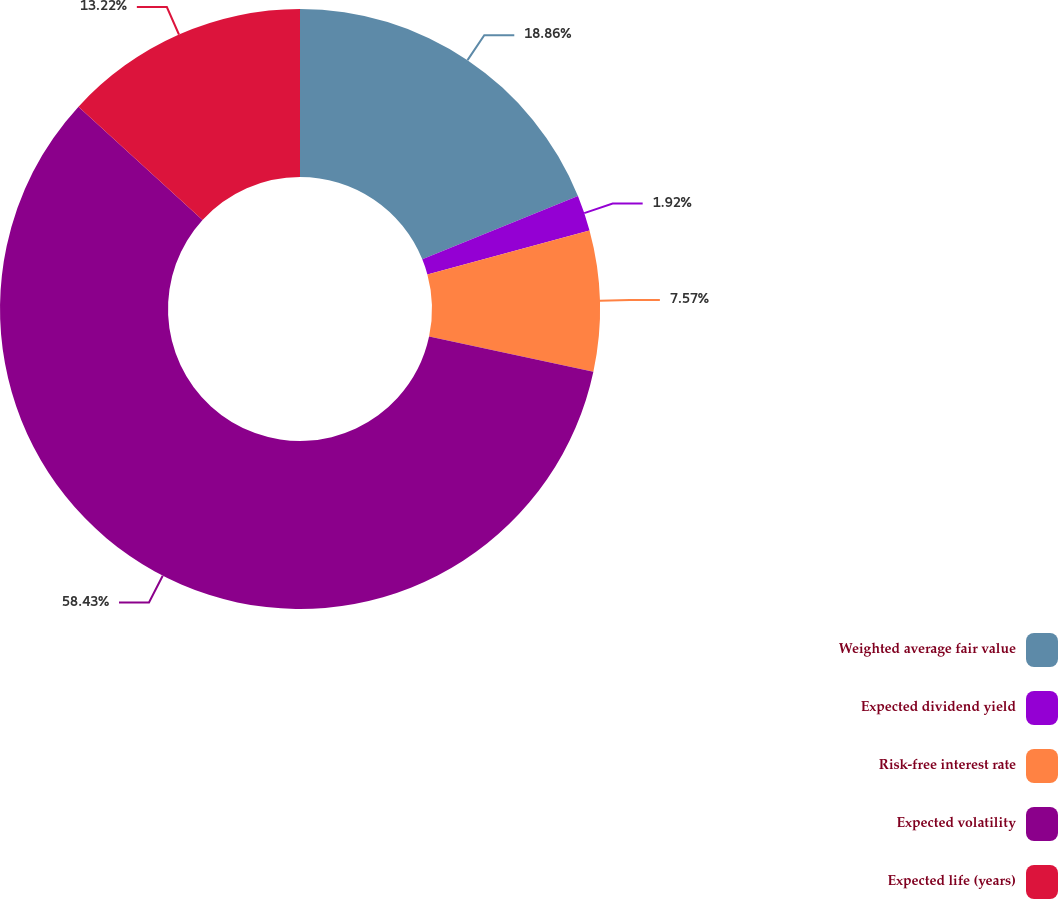<chart> <loc_0><loc_0><loc_500><loc_500><pie_chart><fcel>Weighted average fair value<fcel>Expected dividend yield<fcel>Risk-free interest rate<fcel>Expected volatility<fcel>Expected life (years)<nl><fcel>18.86%<fcel>1.92%<fcel>7.57%<fcel>58.43%<fcel>13.22%<nl></chart> 